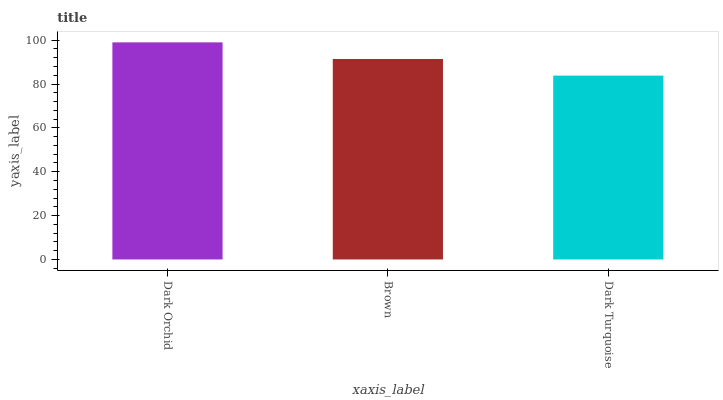Is Brown the minimum?
Answer yes or no. No. Is Brown the maximum?
Answer yes or no. No. Is Dark Orchid greater than Brown?
Answer yes or no. Yes. Is Brown less than Dark Orchid?
Answer yes or no. Yes. Is Brown greater than Dark Orchid?
Answer yes or no. No. Is Dark Orchid less than Brown?
Answer yes or no. No. Is Brown the high median?
Answer yes or no. Yes. Is Brown the low median?
Answer yes or no. Yes. Is Dark Turquoise the high median?
Answer yes or no. No. Is Dark Turquoise the low median?
Answer yes or no. No. 